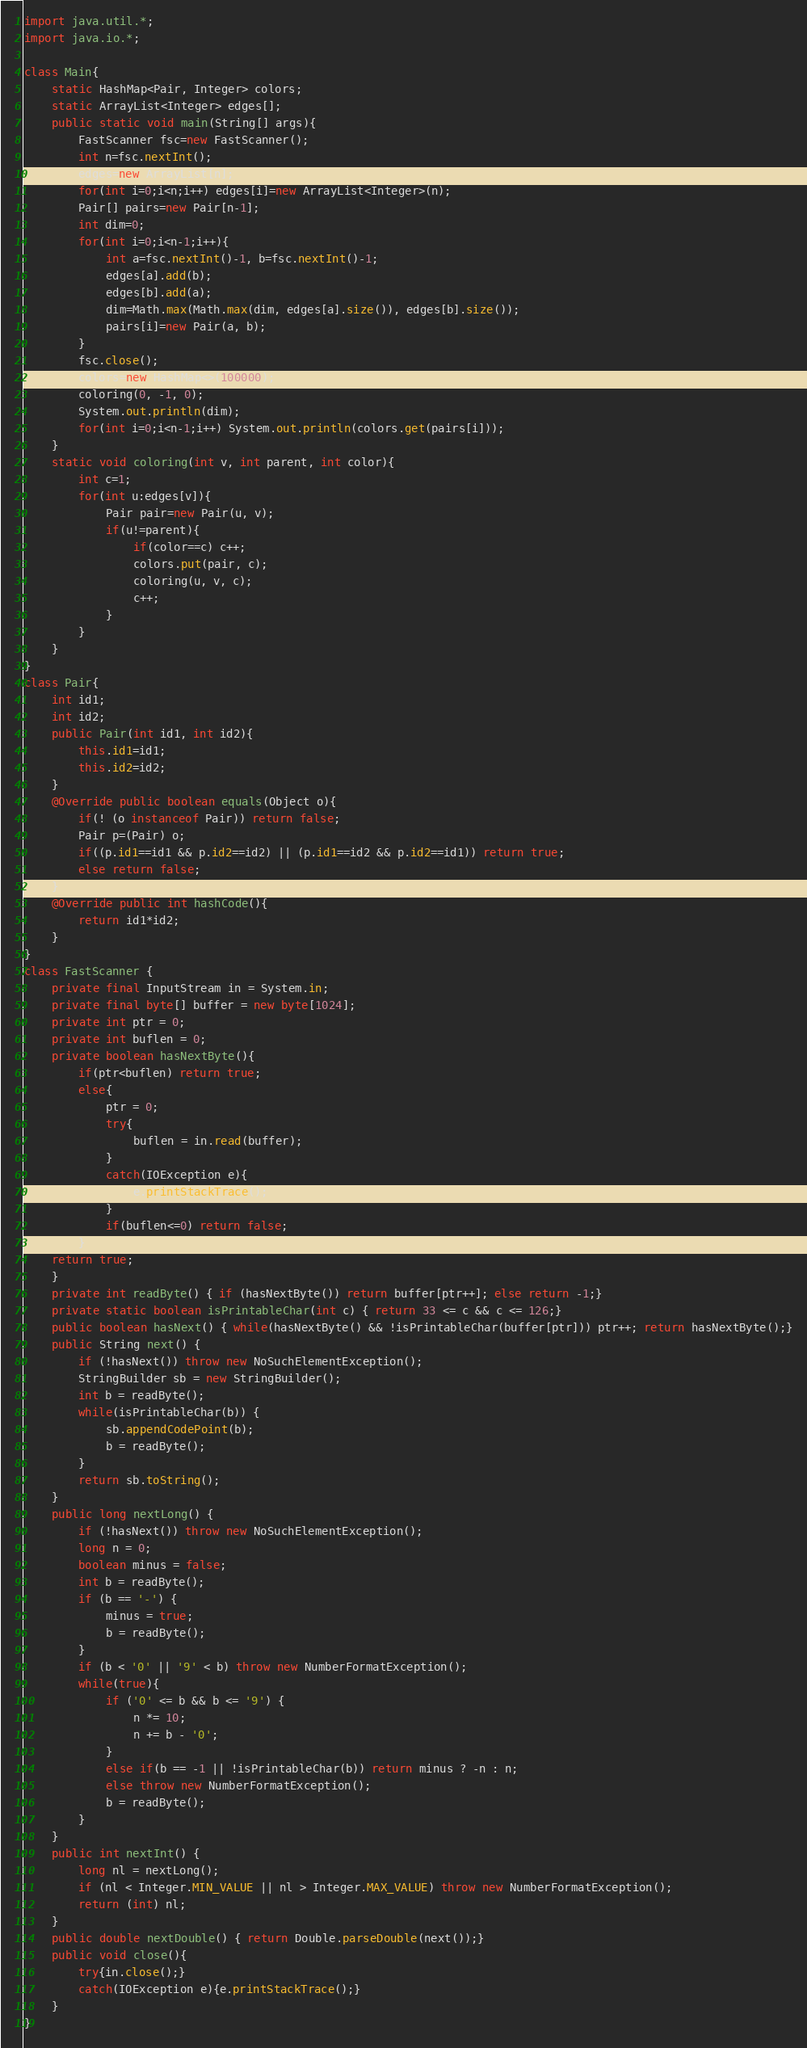Convert code to text. <code><loc_0><loc_0><loc_500><loc_500><_Java_>import java.util.*;
import java.io.*;

class Main{
    static HashMap<Pair, Integer> colors;
    static ArrayList<Integer> edges[];
    public static void main(String[] args){
        FastScanner fsc=new FastScanner();
        int n=fsc.nextInt();
        edges=new ArrayList[n];
        for(int i=0;i<n;i++) edges[i]=new ArrayList<Integer>(n);
        Pair[] pairs=new Pair[n-1];
        int dim=0;
        for(int i=0;i<n-1;i++){
            int a=fsc.nextInt()-1, b=fsc.nextInt()-1;
            edges[a].add(b);
            edges[b].add(a);
            dim=Math.max(Math.max(dim, edges[a].size()), edges[b].size());
            pairs[i]=new Pair(a, b);
        }
        fsc.close();
        colors=new HashMap<>(100000);
        coloring(0, -1, 0);
        System.out.println(dim);
        for(int i=0;i<n-1;i++) System.out.println(colors.get(pairs[i]));
    }
    static void coloring(int v, int parent, int color){
        int c=1;
        for(int u:edges[v]){
            Pair pair=new Pair(u, v);
            if(u!=parent){
                if(color==c) c++;
                colors.put(pair, c);
                coloring(u, v, c);
                c++;
            }
        }
    }
}
class Pair{
    int id1;
    int id2;
    public Pair(int id1, int id2){
        this.id1=id1;
        this.id2=id2;
    }
    @Override public boolean equals(Object o){
        if(! (o instanceof Pair)) return false;
        Pair p=(Pair) o;
        if((p.id1==id1 && p.id2==id2) || (p.id1==id2 && p.id2==id1)) return true;
        else return false;
    }
    @Override public int hashCode(){
        return id1*id2;
    }
}
class FastScanner {
    private final InputStream in = System.in;
    private final byte[] buffer = new byte[1024];
    private int ptr = 0;
    private int buflen = 0;
    private boolean hasNextByte(){
        if(ptr<buflen) return true;
        else{
            ptr = 0;
            try{
                buflen = in.read(buffer);
            }
            catch(IOException e){
                e.printStackTrace();
            }
            if(buflen<=0) return false;
        }
    return true;
    }
    private int readByte() { if (hasNextByte()) return buffer[ptr++]; else return -1;}
    private static boolean isPrintableChar(int c) { return 33 <= c && c <= 126;}
    public boolean hasNext() { while(hasNextByte() && !isPrintableChar(buffer[ptr])) ptr++; return hasNextByte();}
    public String next() {
        if (!hasNext()) throw new NoSuchElementException();
        StringBuilder sb = new StringBuilder();
        int b = readByte();
        while(isPrintableChar(b)) {
            sb.appendCodePoint(b);
            b = readByte();
        }
        return sb.toString();
    }
    public long nextLong() {
        if (!hasNext()) throw new NoSuchElementException();
        long n = 0;
        boolean minus = false;
        int b = readByte();
        if (b == '-') {
            minus = true;
            b = readByte();
        }
        if (b < '0' || '9' < b) throw new NumberFormatException();
        while(true){
            if ('0' <= b && b <= '9') {
                n *= 10;
                n += b - '0';
            }
            else if(b == -1 || !isPrintableChar(b)) return minus ? -n : n;
            else throw new NumberFormatException();
            b = readByte();
        }
    }
    public int nextInt() {
        long nl = nextLong();
        if (nl < Integer.MIN_VALUE || nl > Integer.MAX_VALUE) throw new NumberFormatException();
        return (int) nl;
    }
    public double nextDouble() { return Double.parseDouble(next());}
    public void close(){
        try{in.close();}
        catch(IOException e){e.printStackTrace();}
    }
}
</code> 